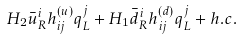<formula> <loc_0><loc_0><loc_500><loc_500>H _ { 2 } \bar { u } _ { R } ^ { i } h _ { i j } ^ { ( u ) } q _ { L } ^ { j } + H _ { 1 } \bar { d } _ { R } ^ { i } h _ { i j } ^ { ( d ) } q _ { L } ^ { j } + h . c .</formula> 